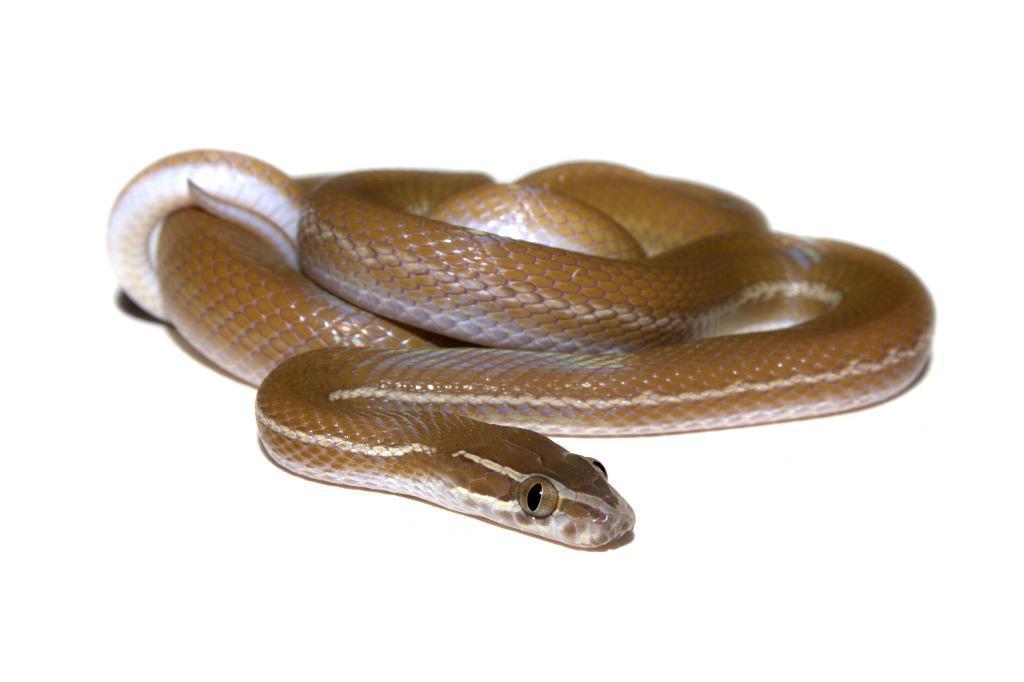How would you summarize this image in a sentence or two? In this image, we can see a snake on the surface. 